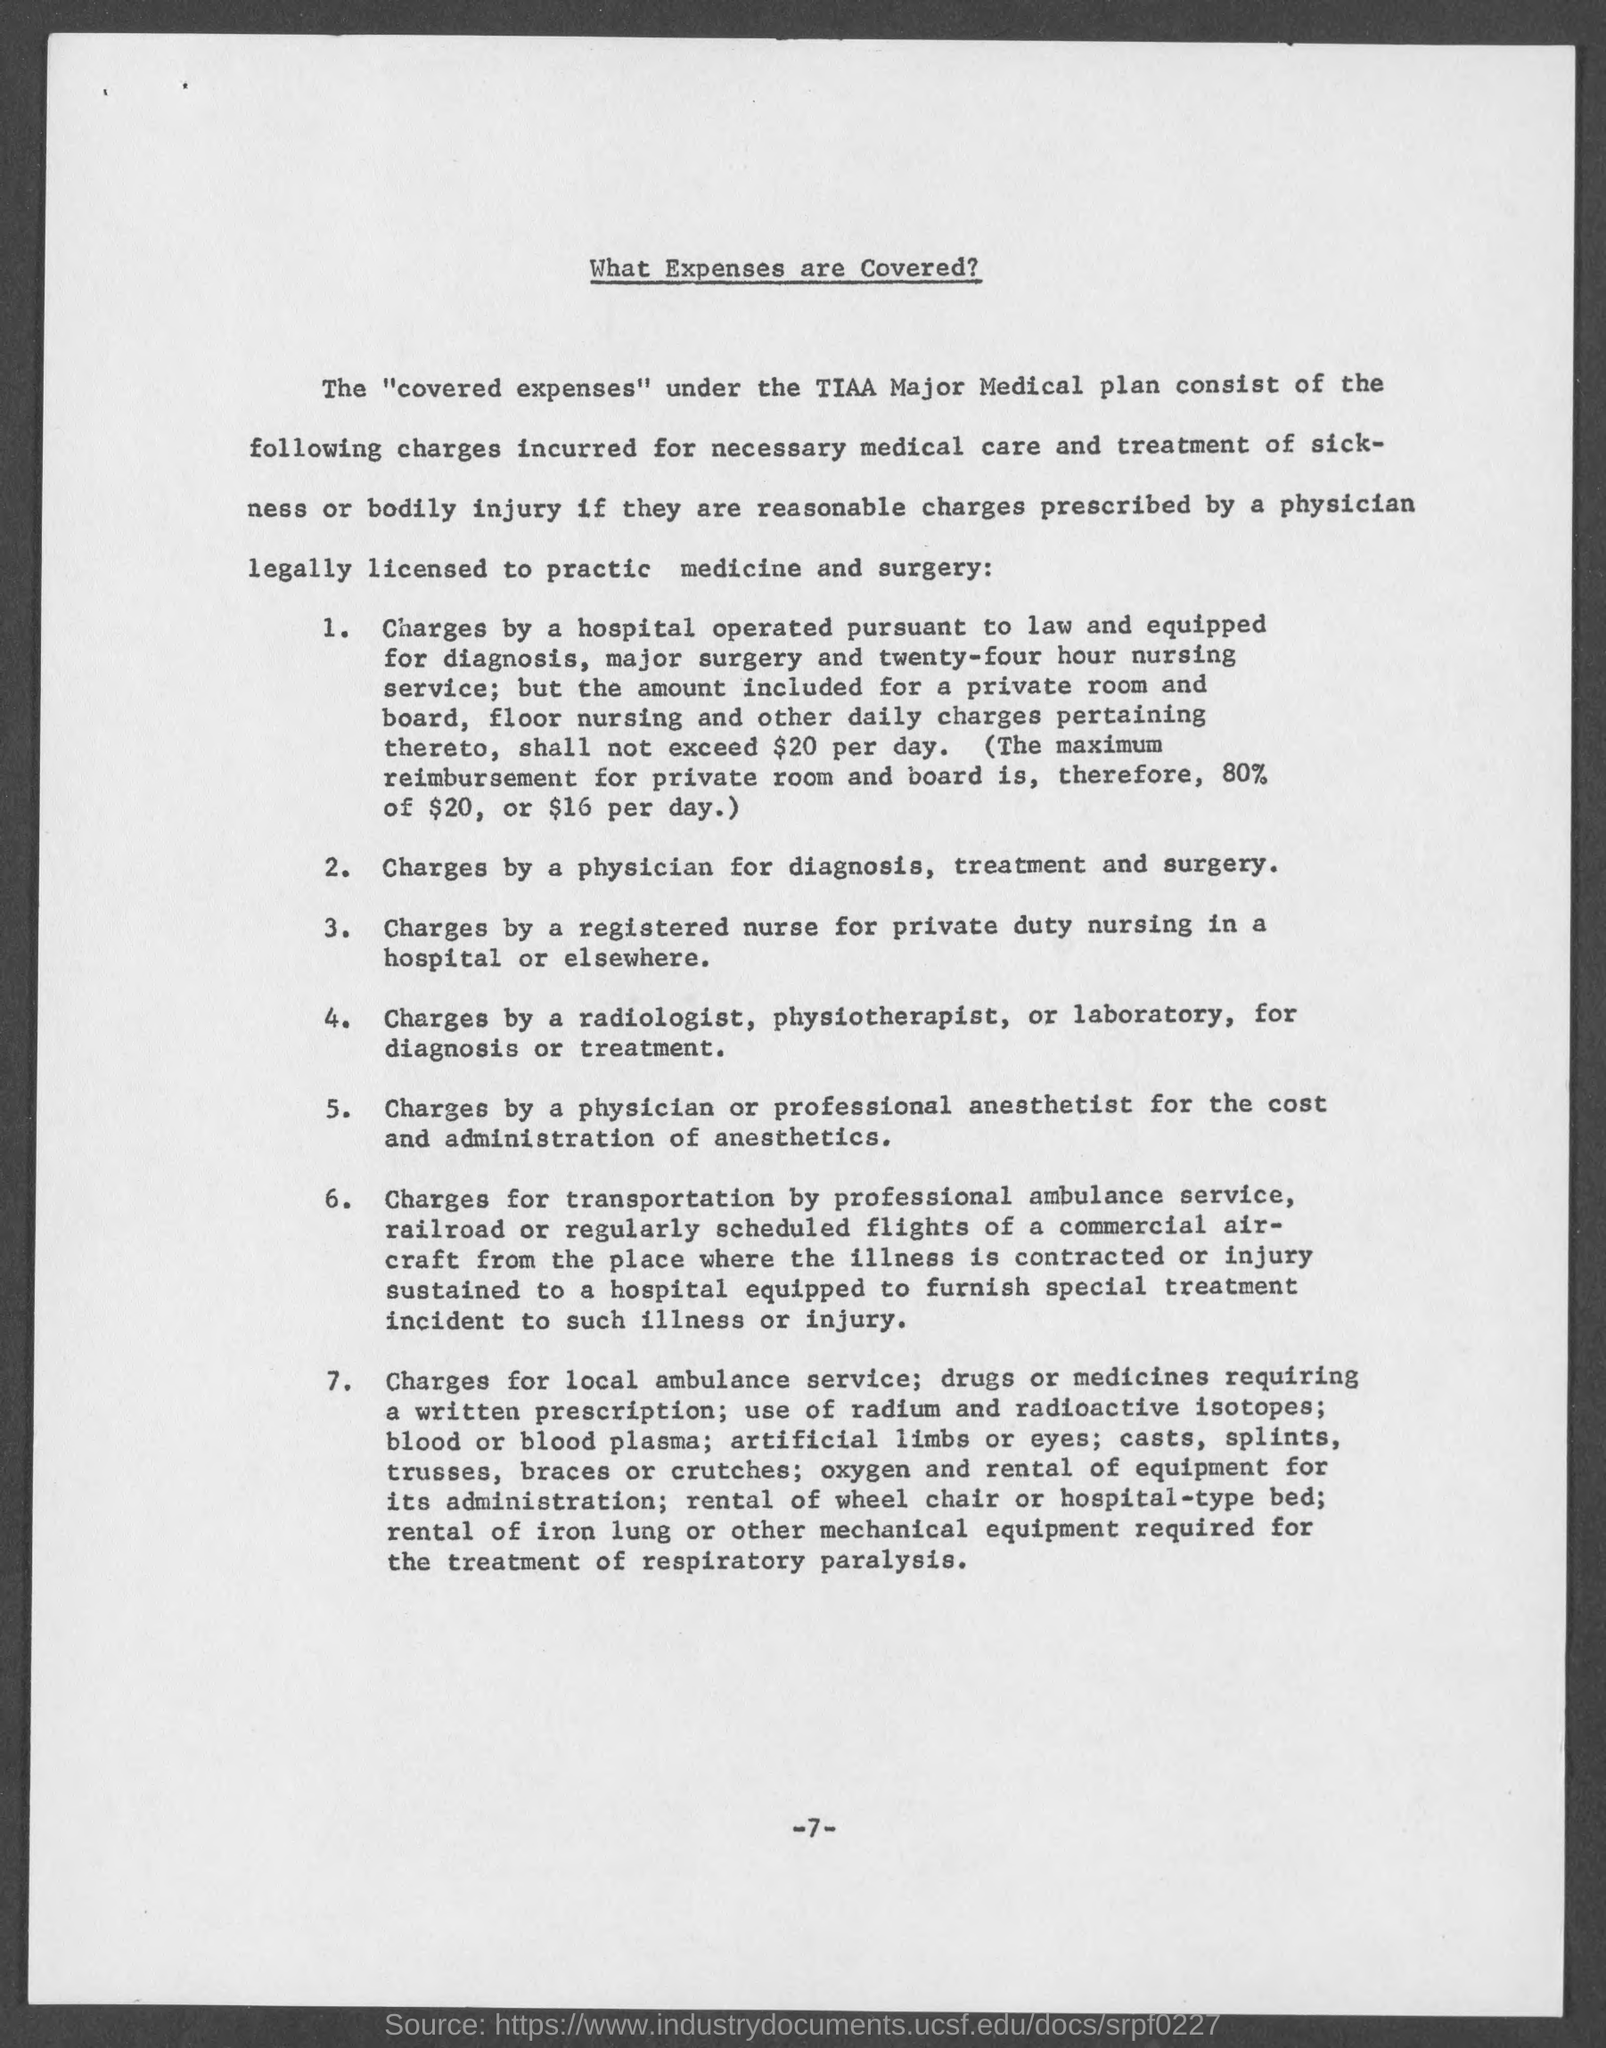What is title of the page?
Make the answer very short. What expenses are covered?. What is the page number at bottom of the page?
Offer a very short reply. 7. 